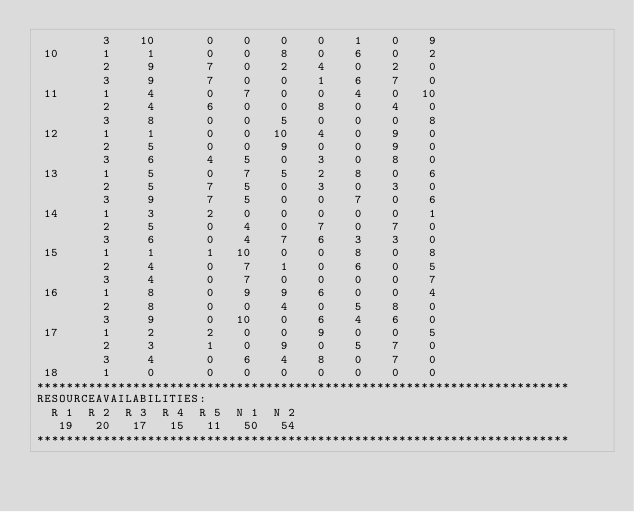<code> <loc_0><loc_0><loc_500><loc_500><_ObjectiveC_>         3    10       0    0    0    0    1    0    9
 10      1     1       0    0    8    0    6    0    2
         2     9       7    0    2    4    0    2    0
         3     9       7    0    0    1    6    7    0
 11      1     4       0    7    0    0    4    0   10
         2     4       6    0    0    8    0    4    0
         3     8       0    0    5    0    0    0    8
 12      1     1       0    0   10    4    0    9    0
         2     5       0    0    9    0    0    9    0
         3     6       4    5    0    3    0    8    0
 13      1     5       0    7    5    2    8    0    6
         2     5       7    5    0    3    0    3    0
         3     9       7    5    0    0    7    0    6
 14      1     3       2    0    0    0    0    0    1
         2     5       0    4    0    7    0    7    0
         3     6       0    4    7    6    3    3    0
 15      1     1       1   10    0    0    8    0    8
         2     4       0    7    1    0    6    0    5
         3     4       0    7    0    0    0    0    7
 16      1     8       0    9    9    6    0    0    4
         2     8       0    0    4    0    5    8    0
         3     9       0   10    0    6    4    6    0
 17      1     2       2    0    0    9    0    0    5
         2     3       1    0    9    0    5    7    0
         3     4       0    6    4    8    0    7    0
 18      1     0       0    0    0    0    0    0    0
************************************************************************
RESOURCEAVAILABILITIES:
  R 1  R 2  R 3  R 4  R 5  N 1  N 2
   19   20   17   15   11   50   54
************************************************************************
</code> 